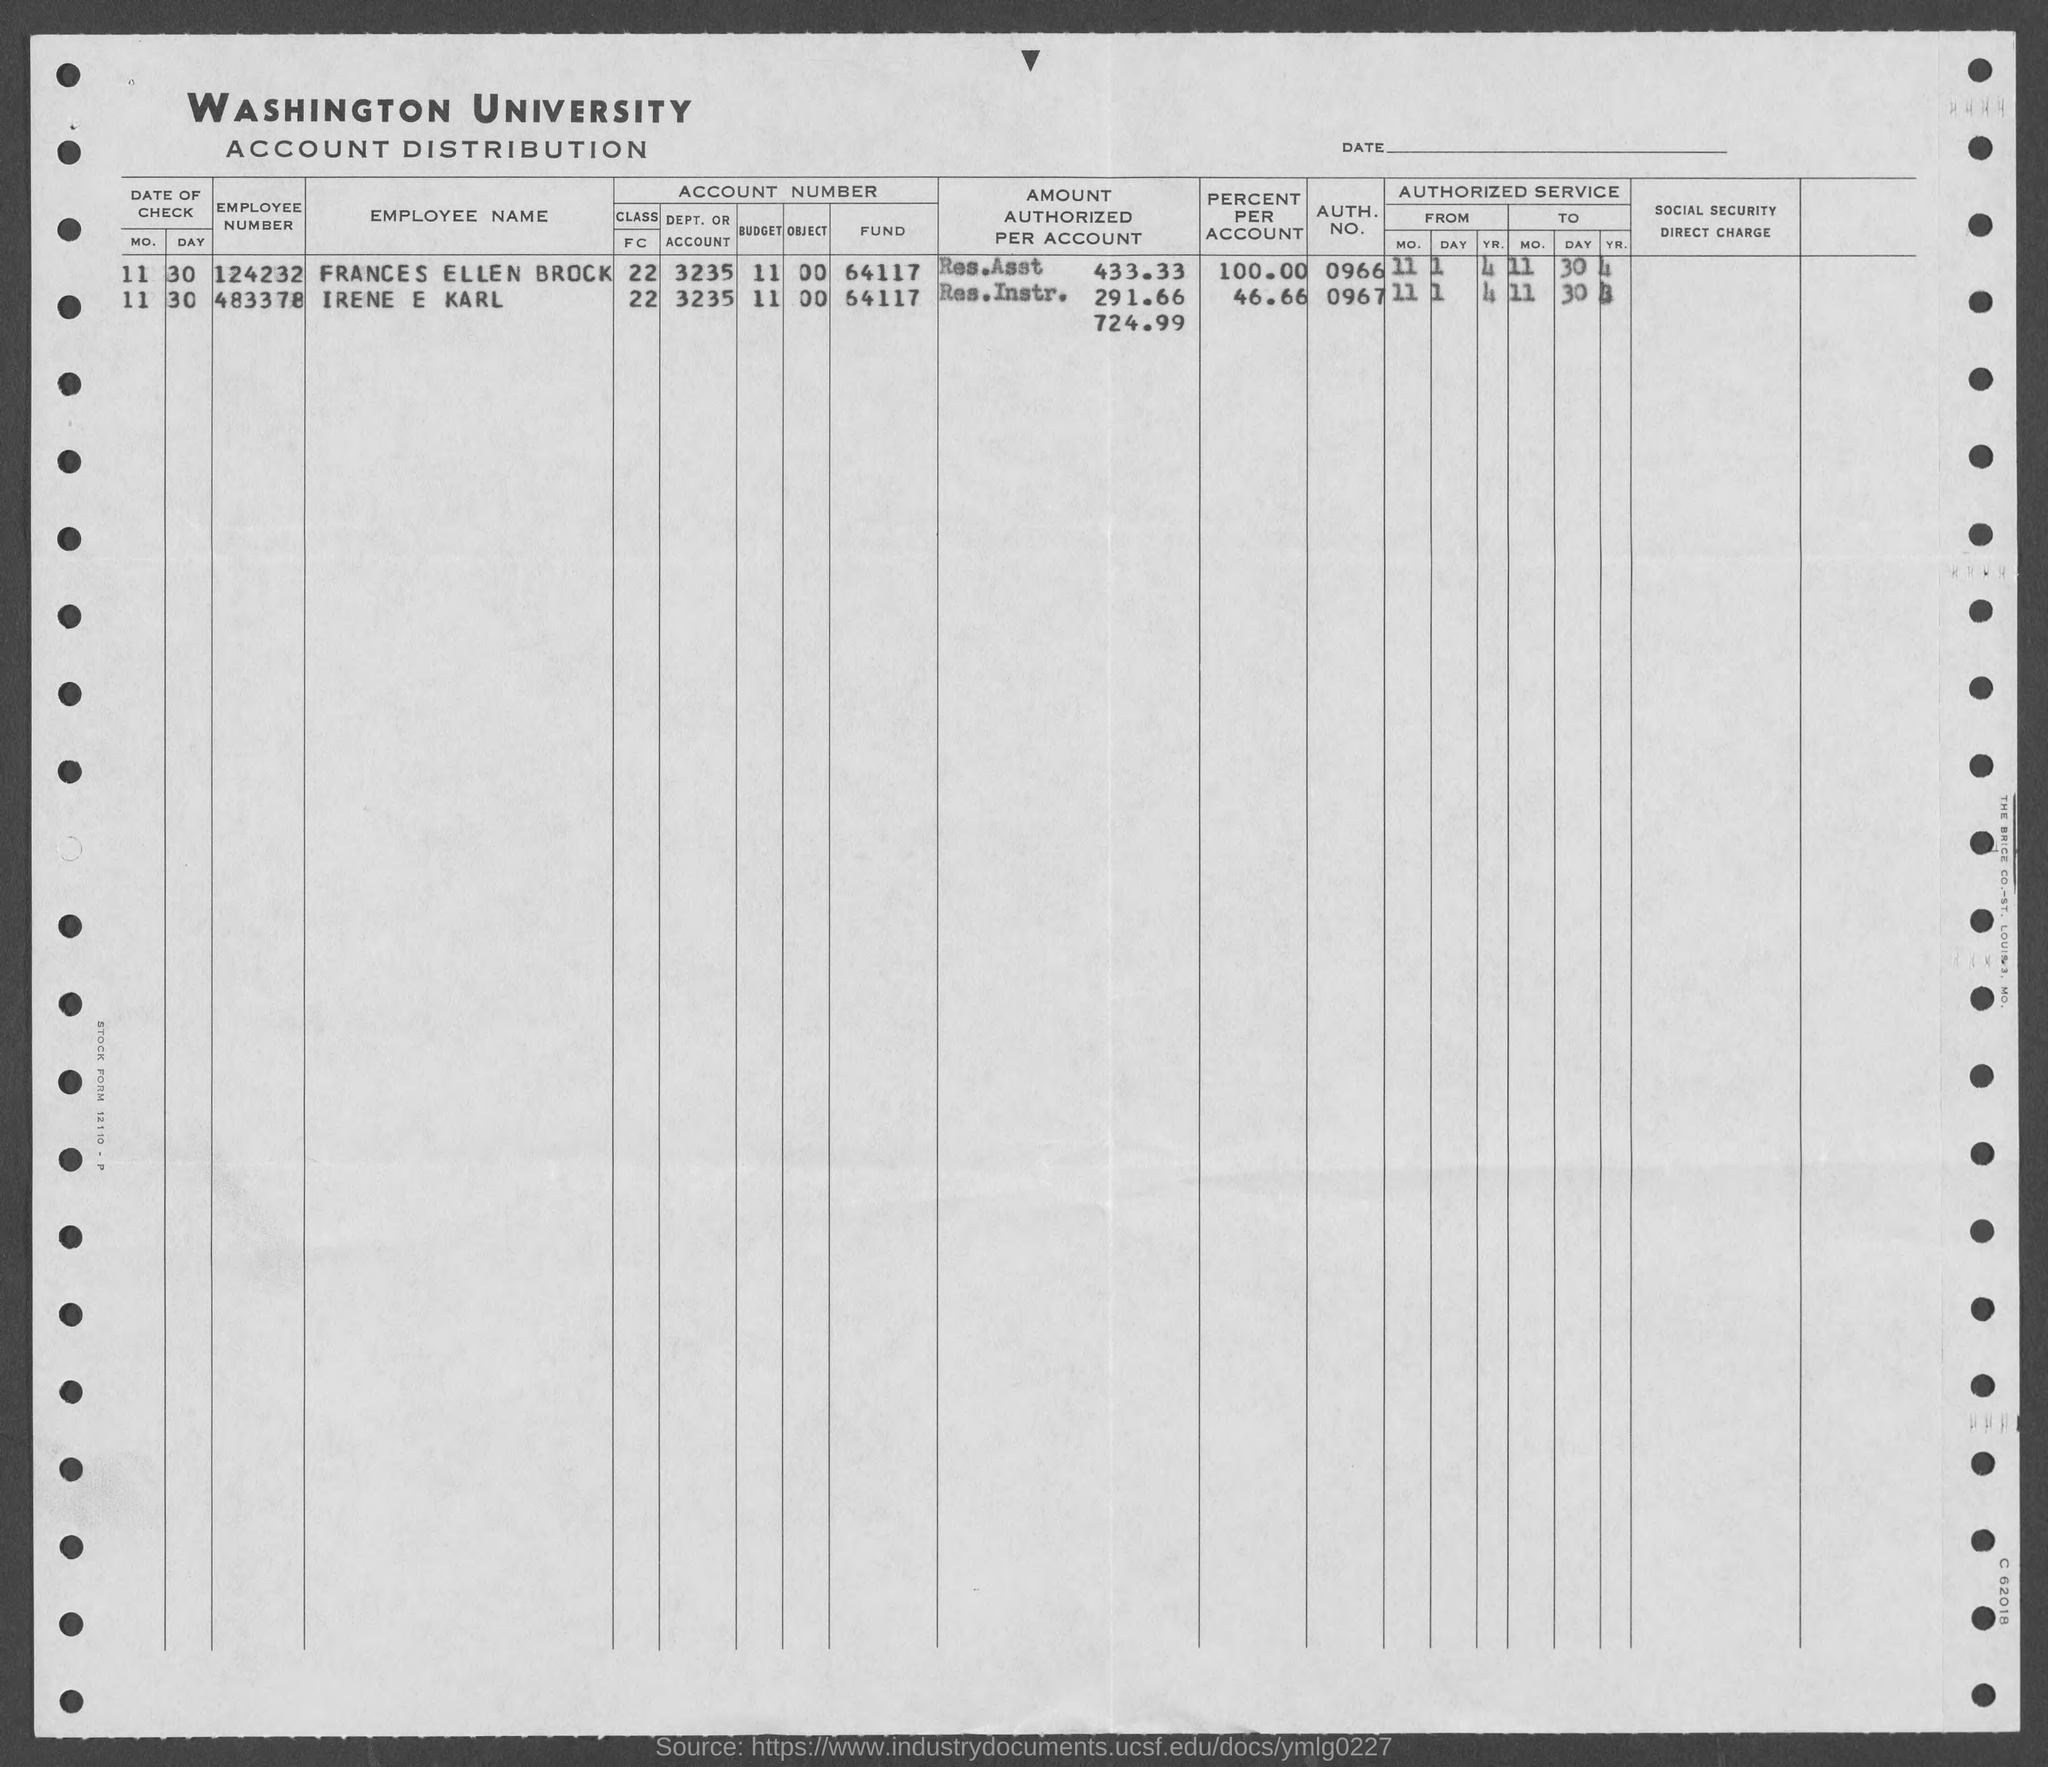What is the employee number of frances ellen brock?
Offer a very short reply. 124232. What is the employee number of irene e karl?
Offer a terse response. 483378. What is auth. no. of frances ellen brock ?
Provide a short and direct response. 0966. What is auth. no. irene e karl?
Provide a short and direct response. 0967. 